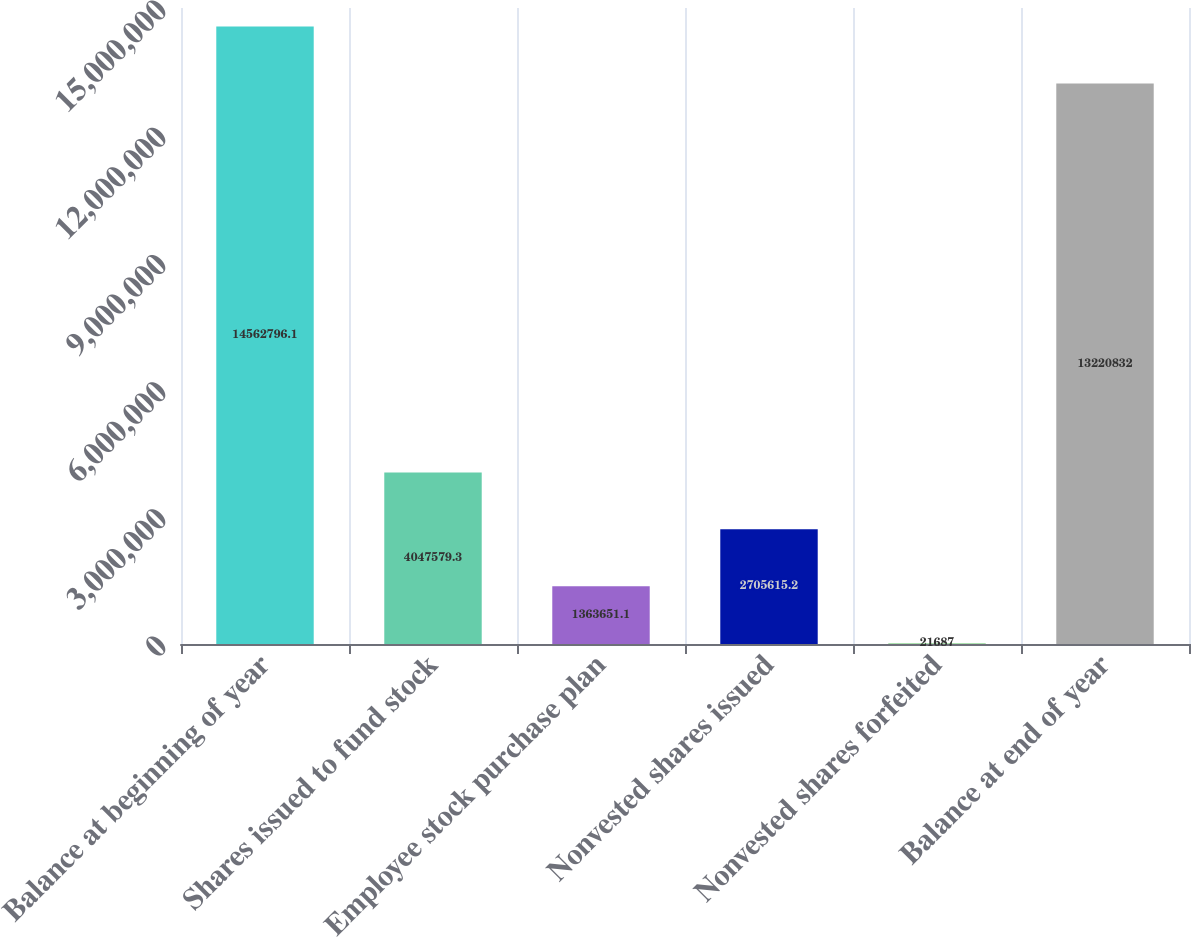Convert chart to OTSL. <chart><loc_0><loc_0><loc_500><loc_500><bar_chart><fcel>Balance at beginning of year<fcel>Shares issued to fund stock<fcel>Employee stock purchase plan<fcel>Nonvested shares issued<fcel>Nonvested shares forfeited<fcel>Balance at end of year<nl><fcel>1.45628e+07<fcel>4.04758e+06<fcel>1.36365e+06<fcel>2.70562e+06<fcel>21687<fcel>1.32208e+07<nl></chart> 